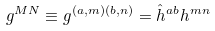<formula> <loc_0><loc_0><loc_500><loc_500>g ^ { M N } \equiv g ^ { ( a , m ) ( b , n ) } = \hat { h } ^ { a b } h ^ { m n }</formula> 